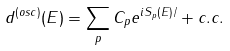<formula> <loc_0><loc_0><loc_500><loc_500>d ^ { ( o s c ) } ( E ) = \sum _ { p } C _ { p } e ^ { i S _ { p } ( E ) / } + c . c .</formula> 